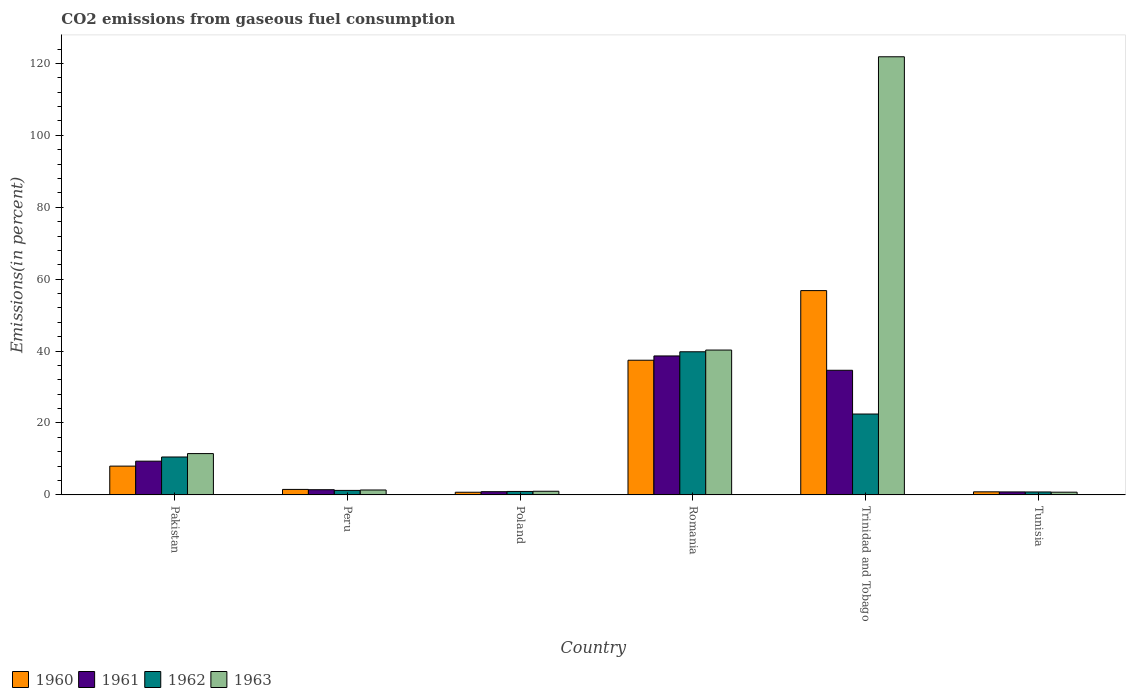How many different coloured bars are there?
Make the answer very short. 4. How many groups of bars are there?
Your answer should be very brief. 6. Are the number of bars per tick equal to the number of legend labels?
Your answer should be compact. Yes. Are the number of bars on each tick of the X-axis equal?
Provide a short and direct response. Yes. What is the label of the 3rd group of bars from the left?
Your answer should be very brief. Poland. In how many cases, is the number of bars for a given country not equal to the number of legend labels?
Offer a terse response. 0. What is the total CO2 emitted in 1961 in Romania?
Give a very brief answer. 38.65. Across all countries, what is the maximum total CO2 emitted in 1960?
Provide a succinct answer. 56.82. Across all countries, what is the minimum total CO2 emitted in 1963?
Make the answer very short. 0.75. In which country was the total CO2 emitted in 1962 maximum?
Offer a terse response. Romania. In which country was the total CO2 emitted in 1961 minimum?
Your response must be concise. Tunisia. What is the total total CO2 emitted in 1963 in the graph?
Provide a succinct answer. 176.75. What is the difference between the total CO2 emitted in 1962 in Pakistan and that in Tunisia?
Make the answer very short. 9.73. What is the difference between the total CO2 emitted in 1961 in Poland and the total CO2 emitted in 1963 in Peru?
Provide a succinct answer. -0.47. What is the average total CO2 emitted in 1961 per country?
Make the answer very short. 14.31. What is the difference between the total CO2 emitted of/in 1961 and total CO2 emitted of/in 1963 in Tunisia?
Keep it short and to the point. 0.08. What is the ratio of the total CO2 emitted in 1961 in Poland to that in Tunisia?
Your answer should be compact. 1.08. Is the total CO2 emitted in 1961 in Romania less than that in Trinidad and Tobago?
Provide a short and direct response. No. Is the difference between the total CO2 emitted in 1961 in Poland and Trinidad and Tobago greater than the difference between the total CO2 emitted in 1963 in Poland and Trinidad and Tobago?
Your answer should be compact. Yes. What is the difference between the highest and the second highest total CO2 emitted in 1960?
Your answer should be compact. 48.81. What is the difference between the highest and the lowest total CO2 emitted in 1961?
Offer a terse response. 37.82. In how many countries, is the total CO2 emitted in 1961 greater than the average total CO2 emitted in 1961 taken over all countries?
Provide a short and direct response. 2. Is it the case that in every country, the sum of the total CO2 emitted in 1961 and total CO2 emitted in 1963 is greater than the sum of total CO2 emitted in 1962 and total CO2 emitted in 1960?
Give a very brief answer. No. What does the 1st bar from the left in Tunisia represents?
Offer a terse response. 1960. What does the 4th bar from the right in Romania represents?
Provide a short and direct response. 1960. How many bars are there?
Your response must be concise. 24. Are all the bars in the graph horizontal?
Offer a very short reply. No. Are the values on the major ticks of Y-axis written in scientific E-notation?
Give a very brief answer. No. Does the graph contain grids?
Your response must be concise. No. Where does the legend appear in the graph?
Ensure brevity in your answer.  Bottom left. How are the legend labels stacked?
Give a very brief answer. Horizontal. What is the title of the graph?
Keep it short and to the point. CO2 emissions from gaseous fuel consumption. What is the label or title of the Y-axis?
Offer a very short reply. Emissions(in percent). What is the Emissions(in percent) in 1960 in Pakistan?
Your response must be concise. 8.01. What is the Emissions(in percent) of 1961 in Pakistan?
Ensure brevity in your answer.  9.38. What is the Emissions(in percent) of 1962 in Pakistan?
Give a very brief answer. 10.54. What is the Emissions(in percent) of 1963 in Pakistan?
Ensure brevity in your answer.  11.49. What is the Emissions(in percent) in 1960 in Peru?
Provide a succinct answer. 1.53. What is the Emissions(in percent) of 1961 in Peru?
Make the answer very short. 1.44. What is the Emissions(in percent) in 1962 in Peru?
Your answer should be very brief. 1.25. What is the Emissions(in percent) in 1963 in Peru?
Your response must be concise. 1.36. What is the Emissions(in percent) of 1960 in Poland?
Offer a terse response. 0.74. What is the Emissions(in percent) in 1961 in Poland?
Provide a short and direct response. 0.89. What is the Emissions(in percent) of 1962 in Poland?
Offer a terse response. 0.96. What is the Emissions(in percent) in 1963 in Poland?
Keep it short and to the point. 1.01. What is the Emissions(in percent) in 1960 in Romania?
Provide a short and direct response. 37.45. What is the Emissions(in percent) of 1961 in Romania?
Offer a very short reply. 38.65. What is the Emissions(in percent) in 1962 in Romania?
Keep it short and to the point. 39.8. What is the Emissions(in percent) in 1963 in Romania?
Offer a terse response. 40.28. What is the Emissions(in percent) of 1960 in Trinidad and Tobago?
Make the answer very short. 56.82. What is the Emissions(in percent) in 1961 in Trinidad and Tobago?
Keep it short and to the point. 34.66. What is the Emissions(in percent) in 1962 in Trinidad and Tobago?
Provide a succinct answer. 22.49. What is the Emissions(in percent) of 1963 in Trinidad and Tobago?
Give a very brief answer. 121.85. What is the Emissions(in percent) of 1960 in Tunisia?
Your answer should be compact. 0.85. What is the Emissions(in percent) in 1961 in Tunisia?
Your answer should be very brief. 0.83. What is the Emissions(in percent) of 1962 in Tunisia?
Your answer should be very brief. 0.82. What is the Emissions(in percent) in 1963 in Tunisia?
Provide a succinct answer. 0.75. Across all countries, what is the maximum Emissions(in percent) in 1960?
Give a very brief answer. 56.82. Across all countries, what is the maximum Emissions(in percent) in 1961?
Provide a short and direct response. 38.65. Across all countries, what is the maximum Emissions(in percent) in 1962?
Your response must be concise. 39.8. Across all countries, what is the maximum Emissions(in percent) in 1963?
Ensure brevity in your answer.  121.85. Across all countries, what is the minimum Emissions(in percent) of 1960?
Provide a succinct answer. 0.74. Across all countries, what is the minimum Emissions(in percent) in 1961?
Provide a succinct answer. 0.83. Across all countries, what is the minimum Emissions(in percent) in 1962?
Provide a short and direct response. 0.82. Across all countries, what is the minimum Emissions(in percent) of 1963?
Give a very brief answer. 0.75. What is the total Emissions(in percent) in 1960 in the graph?
Make the answer very short. 105.39. What is the total Emissions(in percent) of 1961 in the graph?
Keep it short and to the point. 85.86. What is the total Emissions(in percent) in 1962 in the graph?
Give a very brief answer. 75.86. What is the total Emissions(in percent) of 1963 in the graph?
Provide a succinct answer. 176.75. What is the difference between the Emissions(in percent) of 1960 in Pakistan and that in Peru?
Offer a very short reply. 6.48. What is the difference between the Emissions(in percent) of 1961 in Pakistan and that in Peru?
Offer a very short reply. 7.94. What is the difference between the Emissions(in percent) in 1962 in Pakistan and that in Peru?
Offer a very short reply. 9.29. What is the difference between the Emissions(in percent) in 1963 in Pakistan and that in Peru?
Ensure brevity in your answer.  10.13. What is the difference between the Emissions(in percent) of 1960 in Pakistan and that in Poland?
Your answer should be compact. 7.27. What is the difference between the Emissions(in percent) in 1961 in Pakistan and that in Poland?
Your answer should be very brief. 8.49. What is the difference between the Emissions(in percent) in 1962 in Pakistan and that in Poland?
Ensure brevity in your answer.  9.58. What is the difference between the Emissions(in percent) of 1963 in Pakistan and that in Poland?
Your answer should be very brief. 10.47. What is the difference between the Emissions(in percent) in 1960 in Pakistan and that in Romania?
Offer a terse response. -29.45. What is the difference between the Emissions(in percent) in 1961 in Pakistan and that in Romania?
Provide a succinct answer. -29.26. What is the difference between the Emissions(in percent) of 1962 in Pakistan and that in Romania?
Make the answer very short. -29.26. What is the difference between the Emissions(in percent) in 1963 in Pakistan and that in Romania?
Ensure brevity in your answer.  -28.8. What is the difference between the Emissions(in percent) in 1960 in Pakistan and that in Trinidad and Tobago?
Ensure brevity in your answer.  -48.81. What is the difference between the Emissions(in percent) in 1961 in Pakistan and that in Trinidad and Tobago?
Your answer should be compact. -25.28. What is the difference between the Emissions(in percent) of 1962 in Pakistan and that in Trinidad and Tobago?
Keep it short and to the point. -11.95. What is the difference between the Emissions(in percent) of 1963 in Pakistan and that in Trinidad and Tobago?
Your response must be concise. -110.36. What is the difference between the Emissions(in percent) in 1960 in Pakistan and that in Tunisia?
Keep it short and to the point. 7.16. What is the difference between the Emissions(in percent) of 1961 in Pakistan and that in Tunisia?
Your answer should be very brief. 8.55. What is the difference between the Emissions(in percent) in 1962 in Pakistan and that in Tunisia?
Provide a succinct answer. 9.73. What is the difference between the Emissions(in percent) of 1963 in Pakistan and that in Tunisia?
Provide a succinct answer. 10.73. What is the difference between the Emissions(in percent) in 1960 in Peru and that in Poland?
Your answer should be very brief. 0.79. What is the difference between the Emissions(in percent) in 1961 in Peru and that in Poland?
Offer a very short reply. 0.55. What is the difference between the Emissions(in percent) in 1962 in Peru and that in Poland?
Give a very brief answer. 0.29. What is the difference between the Emissions(in percent) of 1963 in Peru and that in Poland?
Provide a short and direct response. 0.35. What is the difference between the Emissions(in percent) of 1960 in Peru and that in Romania?
Your answer should be compact. -35.93. What is the difference between the Emissions(in percent) in 1961 in Peru and that in Romania?
Make the answer very short. -37.2. What is the difference between the Emissions(in percent) of 1962 in Peru and that in Romania?
Give a very brief answer. -38.55. What is the difference between the Emissions(in percent) of 1963 in Peru and that in Romania?
Keep it short and to the point. -38.92. What is the difference between the Emissions(in percent) of 1960 in Peru and that in Trinidad and Tobago?
Give a very brief answer. -55.29. What is the difference between the Emissions(in percent) of 1961 in Peru and that in Trinidad and Tobago?
Your answer should be compact. -33.22. What is the difference between the Emissions(in percent) of 1962 in Peru and that in Trinidad and Tobago?
Ensure brevity in your answer.  -21.24. What is the difference between the Emissions(in percent) in 1963 in Peru and that in Trinidad and Tobago?
Ensure brevity in your answer.  -120.49. What is the difference between the Emissions(in percent) of 1960 in Peru and that in Tunisia?
Provide a short and direct response. 0.68. What is the difference between the Emissions(in percent) of 1961 in Peru and that in Tunisia?
Give a very brief answer. 0.61. What is the difference between the Emissions(in percent) of 1962 in Peru and that in Tunisia?
Your response must be concise. 0.43. What is the difference between the Emissions(in percent) in 1963 in Peru and that in Tunisia?
Your answer should be very brief. 0.61. What is the difference between the Emissions(in percent) in 1960 in Poland and that in Romania?
Ensure brevity in your answer.  -36.72. What is the difference between the Emissions(in percent) of 1961 in Poland and that in Romania?
Ensure brevity in your answer.  -37.75. What is the difference between the Emissions(in percent) in 1962 in Poland and that in Romania?
Make the answer very short. -38.85. What is the difference between the Emissions(in percent) of 1963 in Poland and that in Romania?
Make the answer very short. -39.27. What is the difference between the Emissions(in percent) of 1960 in Poland and that in Trinidad and Tobago?
Provide a short and direct response. -56.08. What is the difference between the Emissions(in percent) in 1961 in Poland and that in Trinidad and Tobago?
Provide a succinct answer. -33.77. What is the difference between the Emissions(in percent) in 1962 in Poland and that in Trinidad and Tobago?
Provide a succinct answer. -21.53. What is the difference between the Emissions(in percent) of 1963 in Poland and that in Trinidad and Tobago?
Your response must be concise. -120.84. What is the difference between the Emissions(in percent) of 1960 in Poland and that in Tunisia?
Ensure brevity in your answer.  -0.11. What is the difference between the Emissions(in percent) of 1961 in Poland and that in Tunisia?
Your answer should be compact. 0.06. What is the difference between the Emissions(in percent) in 1962 in Poland and that in Tunisia?
Give a very brief answer. 0.14. What is the difference between the Emissions(in percent) of 1963 in Poland and that in Tunisia?
Provide a succinct answer. 0.26. What is the difference between the Emissions(in percent) of 1960 in Romania and that in Trinidad and Tobago?
Your answer should be compact. -19.37. What is the difference between the Emissions(in percent) of 1961 in Romania and that in Trinidad and Tobago?
Your answer should be very brief. 3.98. What is the difference between the Emissions(in percent) in 1962 in Romania and that in Trinidad and Tobago?
Offer a very short reply. 17.31. What is the difference between the Emissions(in percent) of 1963 in Romania and that in Trinidad and Tobago?
Your answer should be very brief. -81.57. What is the difference between the Emissions(in percent) of 1960 in Romania and that in Tunisia?
Give a very brief answer. 36.6. What is the difference between the Emissions(in percent) of 1961 in Romania and that in Tunisia?
Make the answer very short. 37.82. What is the difference between the Emissions(in percent) in 1962 in Romania and that in Tunisia?
Keep it short and to the point. 38.99. What is the difference between the Emissions(in percent) in 1963 in Romania and that in Tunisia?
Make the answer very short. 39.53. What is the difference between the Emissions(in percent) of 1960 in Trinidad and Tobago and that in Tunisia?
Give a very brief answer. 55.97. What is the difference between the Emissions(in percent) of 1961 in Trinidad and Tobago and that in Tunisia?
Your answer should be compact. 33.83. What is the difference between the Emissions(in percent) of 1962 in Trinidad and Tobago and that in Tunisia?
Your response must be concise. 21.68. What is the difference between the Emissions(in percent) of 1963 in Trinidad and Tobago and that in Tunisia?
Offer a terse response. 121.1. What is the difference between the Emissions(in percent) in 1960 in Pakistan and the Emissions(in percent) in 1961 in Peru?
Make the answer very short. 6.56. What is the difference between the Emissions(in percent) of 1960 in Pakistan and the Emissions(in percent) of 1962 in Peru?
Your answer should be compact. 6.75. What is the difference between the Emissions(in percent) of 1960 in Pakistan and the Emissions(in percent) of 1963 in Peru?
Your response must be concise. 6.64. What is the difference between the Emissions(in percent) of 1961 in Pakistan and the Emissions(in percent) of 1962 in Peru?
Ensure brevity in your answer.  8.13. What is the difference between the Emissions(in percent) in 1961 in Pakistan and the Emissions(in percent) in 1963 in Peru?
Your response must be concise. 8.02. What is the difference between the Emissions(in percent) of 1962 in Pakistan and the Emissions(in percent) of 1963 in Peru?
Offer a very short reply. 9.18. What is the difference between the Emissions(in percent) in 1960 in Pakistan and the Emissions(in percent) in 1961 in Poland?
Your answer should be compact. 7.11. What is the difference between the Emissions(in percent) of 1960 in Pakistan and the Emissions(in percent) of 1962 in Poland?
Provide a succinct answer. 7.05. What is the difference between the Emissions(in percent) of 1960 in Pakistan and the Emissions(in percent) of 1963 in Poland?
Provide a succinct answer. 6.99. What is the difference between the Emissions(in percent) of 1961 in Pakistan and the Emissions(in percent) of 1962 in Poland?
Keep it short and to the point. 8.42. What is the difference between the Emissions(in percent) of 1961 in Pakistan and the Emissions(in percent) of 1963 in Poland?
Your response must be concise. 8.37. What is the difference between the Emissions(in percent) in 1962 in Pakistan and the Emissions(in percent) in 1963 in Poland?
Give a very brief answer. 9.53. What is the difference between the Emissions(in percent) of 1960 in Pakistan and the Emissions(in percent) of 1961 in Romania?
Your answer should be compact. -30.64. What is the difference between the Emissions(in percent) in 1960 in Pakistan and the Emissions(in percent) in 1962 in Romania?
Offer a terse response. -31.8. What is the difference between the Emissions(in percent) in 1960 in Pakistan and the Emissions(in percent) in 1963 in Romania?
Your answer should be very brief. -32.28. What is the difference between the Emissions(in percent) in 1961 in Pakistan and the Emissions(in percent) in 1962 in Romania?
Your answer should be compact. -30.42. What is the difference between the Emissions(in percent) in 1961 in Pakistan and the Emissions(in percent) in 1963 in Romania?
Provide a short and direct response. -30.9. What is the difference between the Emissions(in percent) in 1962 in Pakistan and the Emissions(in percent) in 1963 in Romania?
Offer a terse response. -29.74. What is the difference between the Emissions(in percent) in 1960 in Pakistan and the Emissions(in percent) in 1961 in Trinidad and Tobago?
Ensure brevity in your answer.  -26.66. What is the difference between the Emissions(in percent) in 1960 in Pakistan and the Emissions(in percent) in 1962 in Trinidad and Tobago?
Your answer should be very brief. -14.49. What is the difference between the Emissions(in percent) in 1960 in Pakistan and the Emissions(in percent) in 1963 in Trinidad and Tobago?
Provide a succinct answer. -113.84. What is the difference between the Emissions(in percent) in 1961 in Pakistan and the Emissions(in percent) in 1962 in Trinidad and Tobago?
Provide a short and direct response. -13.11. What is the difference between the Emissions(in percent) in 1961 in Pakistan and the Emissions(in percent) in 1963 in Trinidad and Tobago?
Your answer should be compact. -112.47. What is the difference between the Emissions(in percent) in 1962 in Pakistan and the Emissions(in percent) in 1963 in Trinidad and Tobago?
Provide a short and direct response. -111.31. What is the difference between the Emissions(in percent) in 1960 in Pakistan and the Emissions(in percent) in 1961 in Tunisia?
Ensure brevity in your answer.  7.18. What is the difference between the Emissions(in percent) of 1960 in Pakistan and the Emissions(in percent) of 1962 in Tunisia?
Your answer should be very brief. 7.19. What is the difference between the Emissions(in percent) in 1960 in Pakistan and the Emissions(in percent) in 1963 in Tunisia?
Ensure brevity in your answer.  7.25. What is the difference between the Emissions(in percent) in 1961 in Pakistan and the Emissions(in percent) in 1962 in Tunisia?
Your response must be concise. 8.57. What is the difference between the Emissions(in percent) of 1961 in Pakistan and the Emissions(in percent) of 1963 in Tunisia?
Provide a short and direct response. 8.63. What is the difference between the Emissions(in percent) in 1962 in Pakistan and the Emissions(in percent) in 1963 in Tunisia?
Your answer should be very brief. 9.79. What is the difference between the Emissions(in percent) in 1960 in Peru and the Emissions(in percent) in 1961 in Poland?
Offer a terse response. 0.63. What is the difference between the Emissions(in percent) of 1960 in Peru and the Emissions(in percent) of 1962 in Poland?
Your answer should be compact. 0.57. What is the difference between the Emissions(in percent) of 1960 in Peru and the Emissions(in percent) of 1963 in Poland?
Make the answer very short. 0.51. What is the difference between the Emissions(in percent) in 1961 in Peru and the Emissions(in percent) in 1962 in Poland?
Your answer should be very brief. 0.48. What is the difference between the Emissions(in percent) of 1961 in Peru and the Emissions(in percent) of 1963 in Poland?
Make the answer very short. 0.43. What is the difference between the Emissions(in percent) in 1962 in Peru and the Emissions(in percent) in 1963 in Poland?
Ensure brevity in your answer.  0.24. What is the difference between the Emissions(in percent) of 1960 in Peru and the Emissions(in percent) of 1961 in Romania?
Your response must be concise. -37.12. What is the difference between the Emissions(in percent) in 1960 in Peru and the Emissions(in percent) in 1962 in Romania?
Keep it short and to the point. -38.28. What is the difference between the Emissions(in percent) of 1960 in Peru and the Emissions(in percent) of 1963 in Romania?
Give a very brief answer. -38.76. What is the difference between the Emissions(in percent) of 1961 in Peru and the Emissions(in percent) of 1962 in Romania?
Your answer should be compact. -38.36. What is the difference between the Emissions(in percent) of 1961 in Peru and the Emissions(in percent) of 1963 in Romania?
Make the answer very short. -38.84. What is the difference between the Emissions(in percent) in 1962 in Peru and the Emissions(in percent) in 1963 in Romania?
Your response must be concise. -39.03. What is the difference between the Emissions(in percent) in 1960 in Peru and the Emissions(in percent) in 1961 in Trinidad and Tobago?
Ensure brevity in your answer.  -33.14. What is the difference between the Emissions(in percent) in 1960 in Peru and the Emissions(in percent) in 1962 in Trinidad and Tobago?
Your answer should be very brief. -20.97. What is the difference between the Emissions(in percent) of 1960 in Peru and the Emissions(in percent) of 1963 in Trinidad and Tobago?
Your answer should be compact. -120.32. What is the difference between the Emissions(in percent) in 1961 in Peru and the Emissions(in percent) in 1962 in Trinidad and Tobago?
Offer a terse response. -21.05. What is the difference between the Emissions(in percent) in 1961 in Peru and the Emissions(in percent) in 1963 in Trinidad and Tobago?
Offer a terse response. -120.41. What is the difference between the Emissions(in percent) of 1962 in Peru and the Emissions(in percent) of 1963 in Trinidad and Tobago?
Offer a terse response. -120.6. What is the difference between the Emissions(in percent) in 1960 in Peru and the Emissions(in percent) in 1961 in Tunisia?
Offer a very short reply. 0.7. What is the difference between the Emissions(in percent) of 1960 in Peru and the Emissions(in percent) of 1962 in Tunisia?
Provide a short and direct response. 0.71. What is the difference between the Emissions(in percent) in 1960 in Peru and the Emissions(in percent) in 1963 in Tunisia?
Your response must be concise. 0.77. What is the difference between the Emissions(in percent) of 1961 in Peru and the Emissions(in percent) of 1962 in Tunisia?
Ensure brevity in your answer.  0.63. What is the difference between the Emissions(in percent) of 1961 in Peru and the Emissions(in percent) of 1963 in Tunisia?
Keep it short and to the point. 0.69. What is the difference between the Emissions(in percent) of 1962 in Peru and the Emissions(in percent) of 1963 in Tunisia?
Your answer should be compact. 0.5. What is the difference between the Emissions(in percent) of 1960 in Poland and the Emissions(in percent) of 1961 in Romania?
Your response must be concise. -37.91. What is the difference between the Emissions(in percent) of 1960 in Poland and the Emissions(in percent) of 1962 in Romania?
Offer a terse response. -39.07. What is the difference between the Emissions(in percent) in 1960 in Poland and the Emissions(in percent) in 1963 in Romania?
Provide a short and direct response. -39.55. What is the difference between the Emissions(in percent) of 1961 in Poland and the Emissions(in percent) of 1962 in Romania?
Provide a succinct answer. -38.91. What is the difference between the Emissions(in percent) in 1961 in Poland and the Emissions(in percent) in 1963 in Romania?
Keep it short and to the point. -39.39. What is the difference between the Emissions(in percent) in 1962 in Poland and the Emissions(in percent) in 1963 in Romania?
Provide a short and direct response. -39.32. What is the difference between the Emissions(in percent) in 1960 in Poland and the Emissions(in percent) in 1961 in Trinidad and Tobago?
Provide a succinct answer. -33.93. What is the difference between the Emissions(in percent) of 1960 in Poland and the Emissions(in percent) of 1962 in Trinidad and Tobago?
Provide a succinct answer. -21.76. What is the difference between the Emissions(in percent) of 1960 in Poland and the Emissions(in percent) of 1963 in Trinidad and Tobago?
Provide a succinct answer. -121.11. What is the difference between the Emissions(in percent) of 1961 in Poland and the Emissions(in percent) of 1962 in Trinidad and Tobago?
Keep it short and to the point. -21.6. What is the difference between the Emissions(in percent) of 1961 in Poland and the Emissions(in percent) of 1963 in Trinidad and Tobago?
Give a very brief answer. -120.95. What is the difference between the Emissions(in percent) of 1962 in Poland and the Emissions(in percent) of 1963 in Trinidad and Tobago?
Your answer should be very brief. -120.89. What is the difference between the Emissions(in percent) in 1960 in Poland and the Emissions(in percent) in 1961 in Tunisia?
Keep it short and to the point. -0.09. What is the difference between the Emissions(in percent) in 1960 in Poland and the Emissions(in percent) in 1962 in Tunisia?
Offer a terse response. -0.08. What is the difference between the Emissions(in percent) of 1960 in Poland and the Emissions(in percent) of 1963 in Tunisia?
Your answer should be compact. -0.02. What is the difference between the Emissions(in percent) of 1961 in Poland and the Emissions(in percent) of 1962 in Tunisia?
Your answer should be compact. 0.08. What is the difference between the Emissions(in percent) of 1961 in Poland and the Emissions(in percent) of 1963 in Tunisia?
Provide a short and direct response. 0.14. What is the difference between the Emissions(in percent) of 1962 in Poland and the Emissions(in percent) of 1963 in Tunisia?
Your response must be concise. 0.21. What is the difference between the Emissions(in percent) in 1960 in Romania and the Emissions(in percent) in 1961 in Trinidad and Tobago?
Your response must be concise. 2.79. What is the difference between the Emissions(in percent) of 1960 in Romania and the Emissions(in percent) of 1962 in Trinidad and Tobago?
Make the answer very short. 14.96. What is the difference between the Emissions(in percent) in 1960 in Romania and the Emissions(in percent) in 1963 in Trinidad and Tobago?
Provide a short and direct response. -84.4. What is the difference between the Emissions(in percent) of 1961 in Romania and the Emissions(in percent) of 1962 in Trinidad and Tobago?
Offer a terse response. 16.15. What is the difference between the Emissions(in percent) of 1961 in Romania and the Emissions(in percent) of 1963 in Trinidad and Tobago?
Give a very brief answer. -83.2. What is the difference between the Emissions(in percent) in 1962 in Romania and the Emissions(in percent) in 1963 in Trinidad and Tobago?
Provide a short and direct response. -82.04. What is the difference between the Emissions(in percent) in 1960 in Romania and the Emissions(in percent) in 1961 in Tunisia?
Your answer should be very brief. 36.62. What is the difference between the Emissions(in percent) of 1960 in Romania and the Emissions(in percent) of 1962 in Tunisia?
Offer a very short reply. 36.64. What is the difference between the Emissions(in percent) of 1960 in Romania and the Emissions(in percent) of 1963 in Tunisia?
Provide a short and direct response. 36.7. What is the difference between the Emissions(in percent) of 1961 in Romania and the Emissions(in percent) of 1962 in Tunisia?
Make the answer very short. 37.83. What is the difference between the Emissions(in percent) of 1961 in Romania and the Emissions(in percent) of 1963 in Tunisia?
Ensure brevity in your answer.  37.89. What is the difference between the Emissions(in percent) in 1962 in Romania and the Emissions(in percent) in 1963 in Tunisia?
Offer a very short reply. 39.05. What is the difference between the Emissions(in percent) in 1960 in Trinidad and Tobago and the Emissions(in percent) in 1961 in Tunisia?
Make the answer very short. 55.99. What is the difference between the Emissions(in percent) in 1960 in Trinidad and Tobago and the Emissions(in percent) in 1962 in Tunisia?
Your answer should be compact. 56. What is the difference between the Emissions(in percent) in 1960 in Trinidad and Tobago and the Emissions(in percent) in 1963 in Tunisia?
Your answer should be compact. 56.06. What is the difference between the Emissions(in percent) of 1961 in Trinidad and Tobago and the Emissions(in percent) of 1962 in Tunisia?
Offer a very short reply. 33.84. What is the difference between the Emissions(in percent) in 1961 in Trinidad and Tobago and the Emissions(in percent) in 1963 in Tunisia?
Make the answer very short. 33.91. What is the difference between the Emissions(in percent) of 1962 in Trinidad and Tobago and the Emissions(in percent) of 1963 in Tunisia?
Keep it short and to the point. 21.74. What is the average Emissions(in percent) of 1960 per country?
Your answer should be very brief. 17.56. What is the average Emissions(in percent) in 1961 per country?
Provide a short and direct response. 14.31. What is the average Emissions(in percent) in 1962 per country?
Your answer should be compact. 12.64. What is the average Emissions(in percent) in 1963 per country?
Give a very brief answer. 29.46. What is the difference between the Emissions(in percent) of 1960 and Emissions(in percent) of 1961 in Pakistan?
Your answer should be compact. -1.38. What is the difference between the Emissions(in percent) in 1960 and Emissions(in percent) in 1962 in Pakistan?
Ensure brevity in your answer.  -2.54. What is the difference between the Emissions(in percent) of 1960 and Emissions(in percent) of 1963 in Pakistan?
Your answer should be compact. -3.48. What is the difference between the Emissions(in percent) in 1961 and Emissions(in percent) in 1962 in Pakistan?
Your response must be concise. -1.16. What is the difference between the Emissions(in percent) in 1961 and Emissions(in percent) in 1963 in Pakistan?
Your answer should be compact. -2.11. What is the difference between the Emissions(in percent) of 1962 and Emissions(in percent) of 1963 in Pakistan?
Keep it short and to the point. -0.95. What is the difference between the Emissions(in percent) in 1960 and Emissions(in percent) in 1961 in Peru?
Provide a succinct answer. 0.08. What is the difference between the Emissions(in percent) in 1960 and Emissions(in percent) in 1962 in Peru?
Your answer should be very brief. 0.27. What is the difference between the Emissions(in percent) of 1960 and Emissions(in percent) of 1963 in Peru?
Provide a short and direct response. 0.16. What is the difference between the Emissions(in percent) of 1961 and Emissions(in percent) of 1962 in Peru?
Ensure brevity in your answer.  0.19. What is the difference between the Emissions(in percent) of 1961 and Emissions(in percent) of 1963 in Peru?
Provide a short and direct response. 0.08. What is the difference between the Emissions(in percent) in 1962 and Emissions(in percent) in 1963 in Peru?
Ensure brevity in your answer.  -0.11. What is the difference between the Emissions(in percent) of 1960 and Emissions(in percent) of 1961 in Poland?
Your answer should be very brief. -0.16. What is the difference between the Emissions(in percent) in 1960 and Emissions(in percent) in 1962 in Poland?
Ensure brevity in your answer.  -0.22. What is the difference between the Emissions(in percent) of 1960 and Emissions(in percent) of 1963 in Poland?
Offer a very short reply. -0.28. What is the difference between the Emissions(in percent) of 1961 and Emissions(in percent) of 1962 in Poland?
Give a very brief answer. -0.06. What is the difference between the Emissions(in percent) of 1961 and Emissions(in percent) of 1963 in Poland?
Your answer should be very brief. -0.12. What is the difference between the Emissions(in percent) of 1962 and Emissions(in percent) of 1963 in Poland?
Your answer should be compact. -0.05. What is the difference between the Emissions(in percent) in 1960 and Emissions(in percent) in 1961 in Romania?
Offer a terse response. -1.19. What is the difference between the Emissions(in percent) of 1960 and Emissions(in percent) of 1962 in Romania?
Give a very brief answer. -2.35. What is the difference between the Emissions(in percent) of 1960 and Emissions(in percent) of 1963 in Romania?
Provide a succinct answer. -2.83. What is the difference between the Emissions(in percent) in 1961 and Emissions(in percent) in 1962 in Romania?
Provide a short and direct response. -1.16. What is the difference between the Emissions(in percent) of 1961 and Emissions(in percent) of 1963 in Romania?
Your answer should be very brief. -1.64. What is the difference between the Emissions(in percent) of 1962 and Emissions(in percent) of 1963 in Romania?
Ensure brevity in your answer.  -0.48. What is the difference between the Emissions(in percent) of 1960 and Emissions(in percent) of 1961 in Trinidad and Tobago?
Provide a short and direct response. 22.16. What is the difference between the Emissions(in percent) in 1960 and Emissions(in percent) in 1962 in Trinidad and Tobago?
Your response must be concise. 34.33. What is the difference between the Emissions(in percent) of 1960 and Emissions(in percent) of 1963 in Trinidad and Tobago?
Offer a very short reply. -65.03. What is the difference between the Emissions(in percent) of 1961 and Emissions(in percent) of 1962 in Trinidad and Tobago?
Ensure brevity in your answer.  12.17. What is the difference between the Emissions(in percent) of 1961 and Emissions(in percent) of 1963 in Trinidad and Tobago?
Offer a terse response. -87.19. What is the difference between the Emissions(in percent) in 1962 and Emissions(in percent) in 1963 in Trinidad and Tobago?
Keep it short and to the point. -99.36. What is the difference between the Emissions(in percent) in 1960 and Emissions(in percent) in 1961 in Tunisia?
Your response must be concise. 0.02. What is the difference between the Emissions(in percent) of 1960 and Emissions(in percent) of 1962 in Tunisia?
Your answer should be very brief. 0.03. What is the difference between the Emissions(in percent) in 1960 and Emissions(in percent) in 1963 in Tunisia?
Offer a very short reply. 0.1. What is the difference between the Emissions(in percent) in 1961 and Emissions(in percent) in 1962 in Tunisia?
Make the answer very short. 0.01. What is the difference between the Emissions(in percent) in 1961 and Emissions(in percent) in 1963 in Tunisia?
Make the answer very short. 0.08. What is the difference between the Emissions(in percent) in 1962 and Emissions(in percent) in 1963 in Tunisia?
Offer a very short reply. 0.06. What is the ratio of the Emissions(in percent) in 1960 in Pakistan to that in Peru?
Ensure brevity in your answer.  5.25. What is the ratio of the Emissions(in percent) in 1961 in Pakistan to that in Peru?
Offer a terse response. 6.5. What is the ratio of the Emissions(in percent) of 1962 in Pakistan to that in Peru?
Make the answer very short. 8.43. What is the ratio of the Emissions(in percent) of 1963 in Pakistan to that in Peru?
Offer a terse response. 8.44. What is the ratio of the Emissions(in percent) in 1960 in Pakistan to that in Poland?
Provide a succinct answer. 10.88. What is the ratio of the Emissions(in percent) of 1961 in Pakistan to that in Poland?
Provide a succinct answer. 10.49. What is the ratio of the Emissions(in percent) in 1962 in Pakistan to that in Poland?
Your answer should be compact. 10.99. What is the ratio of the Emissions(in percent) of 1963 in Pakistan to that in Poland?
Ensure brevity in your answer.  11.34. What is the ratio of the Emissions(in percent) of 1960 in Pakistan to that in Romania?
Keep it short and to the point. 0.21. What is the ratio of the Emissions(in percent) in 1961 in Pakistan to that in Romania?
Ensure brevity in your answer.  0.24. What is the ratio of the Emissions(in percent) in 1962 in Pakistan to that in Romania?
Keep it short and to the point. 0.26. What is the ratio of the Emissions(in percent) of 1963 in Pakistan to that in Romania?
Make the answer very short. 0.29. What is the ratio of the Emissions(in percent) of 1960 in Pakistan to that in Trinidad and Tobago?
Your answer should be very brief. 0.14. What is the ratio of the Emissions(in percent) in 1961 in Pakistan to that in Trinidad and Tobago?
Provide a succinct answer. 0.27. What is the ratio of the Emissions(in percent) of 1962 in Pakistan to that in Trinidad and Tobago?
Keep it short and to the point. 0.47. What is the ratio of the Emissions(in percent) of 1963 in Pakistan to that in Trinidad and Tobago?
Your answer should be very brief. 0.09. What is the ratio of the Emissions(in percent) in 1960 in Pakistan to that in Tunisia?
Provide a succinct answer. 9.43. What is the ratio of the Emissions(in percent) in 1961 in Pakistan to that in Tunisia?
Ensure brevity in your answer.  11.31. What is the ratio of the Emissions(in percent) in 1962 in Pakistan to that in Tunisia?
Keep it short and to the point. 12.91. What is the ratio of the Emissions(in percent) in 1963 in Pakistan to that in Tunisia?
Offer a terse response. 15.25. What is the ratio of the Emissions(in percent) of 1960 in Peru to that in Poland?
Your answer should be very brief. 2.07. What is the ratio of the Emissions(in percent) of 1961 in Peru to that in Poland?
Your response must be concise. 1.61. What is the ratio of the Emissions(in percent) in 1962 in Peru to that in Poland?
Your answer should be compact. 1.3. What is the ratio of the Emissions(in percent) of 1963 in Peru to that in Poland?
Provide a succinct answer. 1.34. What is the ratio of the Emissions(in percent) in 1960 in Peru to that in Romania?
Your answer should be compact. 0.04. What is the ratio of the Emissions(in percent) in 1961 in Peru to that in Romania?
Your answer should be compact. 0.04. What is the ratio of the Emissions(in percent) of 1962 in Peru to that in Romania?
Provide a succinct answer. 0.03. What is the ratio of the Emissions(in percent) in 1963 in Peru to that in Romania?
Keep it short and to the point. 0.03. What is the ratio of the Emissions(in percent) of 1960 in Peru to that in Trinidad and Tobago?
Provide a short and direct response. 0.03. What is the ratio of the Emissions(in percent) of 1961 in Peru to that in Trinidad and Tobago?
Ensure brevity in your answer.  0.04. What is the ratio of the Emissions(in percent) of 1962 in Peru to that in Trinidad and Tobago?
Offer a very short reply. 0.06. What is the ratio of the Emissions(in percent) of 1963 in Peru to that in Trinidad and Tobago?
Keep it short and to the point. 0.01. What is the ratio of the Emissions(in percent) in 1960 in Peru to that in Tunisia?
Your answer should be very brief. 1.8. What is the ratio of the Emissions(in percent) in 1961 in Peru to that in Tunisia?
Provide a short and direct response. 1.74. What is the ratio of the Emissions(in percent) in 1962 in Peru to that in Tunisia?
Provide a short and direct response. 1.53. What is the ratio of the Emissions(in percent) in 1963 in Peru to that in Tunisia?
Provide a short and direct response. 1.81. What is the ratio of the Emissions(in percent) in 1960 in Poland to that in Romania?
Keep it short and to the point. 0.02. What is the ratio of the Emissions(in percent) of 1961 in Poland to that in Romania?
Provide a succinct answer. 0.02. What is the ratio of the Emissions(in percent) of 1962 in Poland to that in Romania?
Give a very brief answer. 0.02. What is the ratio of the Emissions(in percent) of 1963 in Poland to that in Romania?
Ensure brevity in your answer.  0.03. What is the ratio of the Emissions(in percent) in 1960 in Poland to that in Trinidad and Tobago?
Keep it short and to the point. 0.01. What is the ratio of the Emissions(in percent) of 1961 in Poland to that in Trinidad and Tobago?
Your answer should be very brief. 0.03. What is the ratio of the Emissions(in percent) of 1962 in Poland to that in Trinidad and Tobago?
Make the answer very short. 0.04. What is the ratio of the Emissions(in percent) in 1963 in Poland to that in Trinidad and Tobago?
Make the answer very short. 0.01. What is the ratio of the Emissions(in percent) in 1960 in Poland to that in Tunisia?
Provide a short and direct response. 0.87. What is the ratio of the Emissions(in percent) in 1961 in Poland to that in Tunisia?
Give a very brief answer. 1.08. What is the ratio of the Emissions(in percent) of 1962 in Poland to that in Tunisia?
Give a very brief answer. 1.17. What is the ratio of the Emissions(in percent) in 1963 in Poland to that in Tunisia?
Keep it short and to the point. 1.35. What is the ratio of the Emissions(in percent) in 1960 in Romania to that in Trinidad and Tobago?
Make the answer very short. 0.66. What is the ratio of the Emissions(in percent) of 1961 in Romania to that in Trinidad and Tobago?
Give a very brief answer. 1.11. What is the ratio of the Emissions(in percent) in 1962 in Romania to that in Trinidad and Tobago?
Make the answer very short. 1.77. What is the ratio of the Emissions(in percent) in 1963 in Romania to that in Trinidad and Tobago?
Make the answer very short. 0.33. What is the ratio of the Emissions(in percent) of 1960 in Romania to that in Tunisia?
Make the answer very short. 44.1. What is the ratio of the Emissions(in percent) in 1961 in Romania to that in Tunisia?
Ensure brevity in your answer.  46.57. What is the ratio of the Emissions(in percent) in 1962 in Romania to that in Tunisia?
Make the answer very short. 48.76. What is the ratio of the Emissions(in percent) of 1963 in Romania to that in Tunisia?
Your answer should be compact. 53.48. What is the ratio of the Emissions(in percent) of 1960 in Trinidad and Tobago to that in Tunisia?
Ensure brevity in your answer.  66.9. What is the ratio of the Emissions(in percent) of 1961 in Trinidad and Tobago to that in Tunisia?
Your answer should be very brief. 41.77. What is the ratio of the Emissions(in percent) in 1962 in Trinidad and Tobago to that in Tunisia?
Your answer should be very brief. 27.55. What is the ratio of the Emissions(in percent) in 1963 in Trinidad and Tobago to that in Tunisia?
Provide a short and direct response. 161.75. What is the difference between the highest and the second highest Emissions(in percent) of 1960?
Your response must be concise. 19.37. What is the difference between the highest and the second highest Emissions(in percent) of 1961?
Give a very brief answer. 3.98. What is the difference between the highest and the second highest Emissions(in percent) in 1962?
Make the answer very short. 17.31. What is the difference between the highest and the second highest Emissions(in percent) in 1963?
Offer a very short reply. 81.57. What is the difference between the highest and the lowest Emissions(in percent) in 1960?
Offer a very short reply. 56.08. What is the difference between the highest and the lowest Emissions(in percent) in 1961?
Make the answer very short. 37.82. What is the difference between the highest and the lowest Emissions(in percent) of 1962?
Make the answer very short. 38.99. What is the difference between the highest and the lowest Emissions(in percent) of 1963?
Make the answer very short. 121.1. 